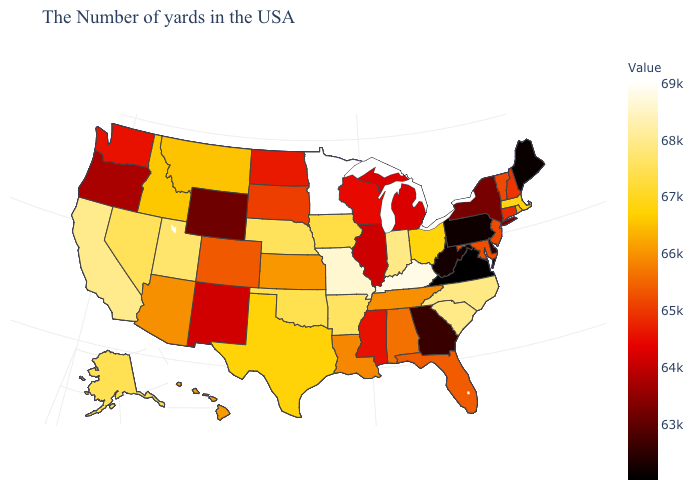Is the legend a continuous bar?
Keep it brief. Yes. Which states have the lowest value in the West?
Be succinct. Wyoming. Does Virginia have the lowest value in the South?
Give a very brief answer. Yes. Does the map have missing data?
Quick response, please. No. Does Montana have the lowest value in the West?
Quick response, please. No. Which states have the lowest value in the USA?
Concise answer only. Virginia. 